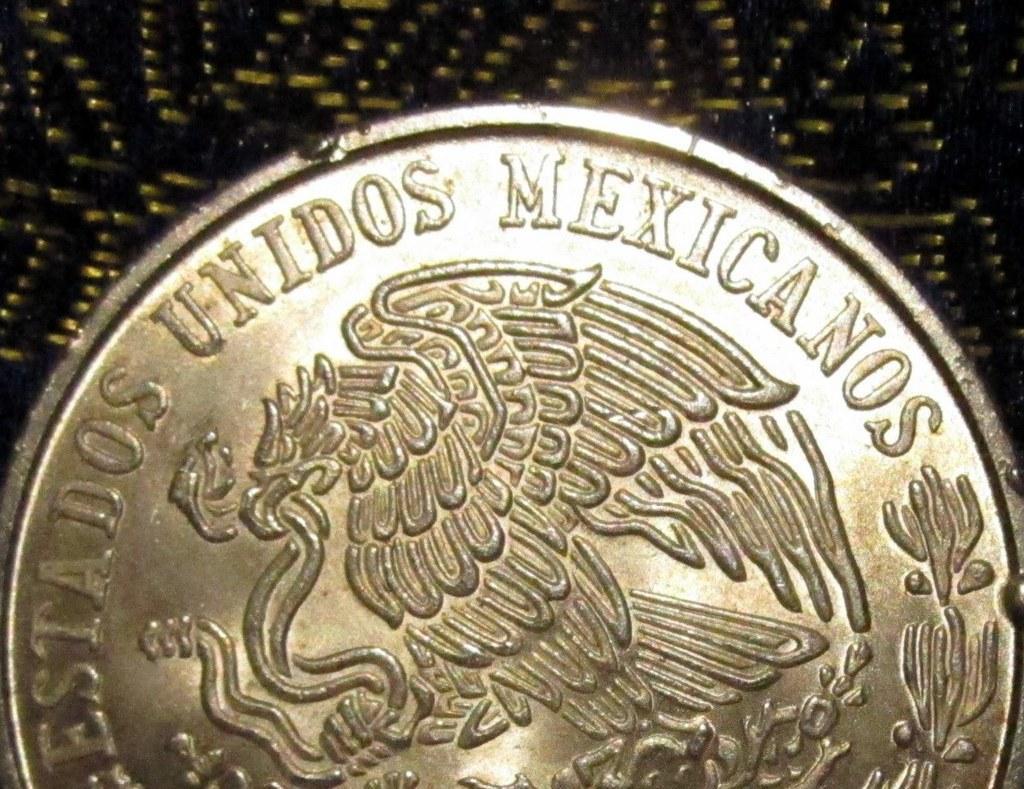How would you summarize this image in a sentence or two? In this image I can see a coin with some text written on it. 